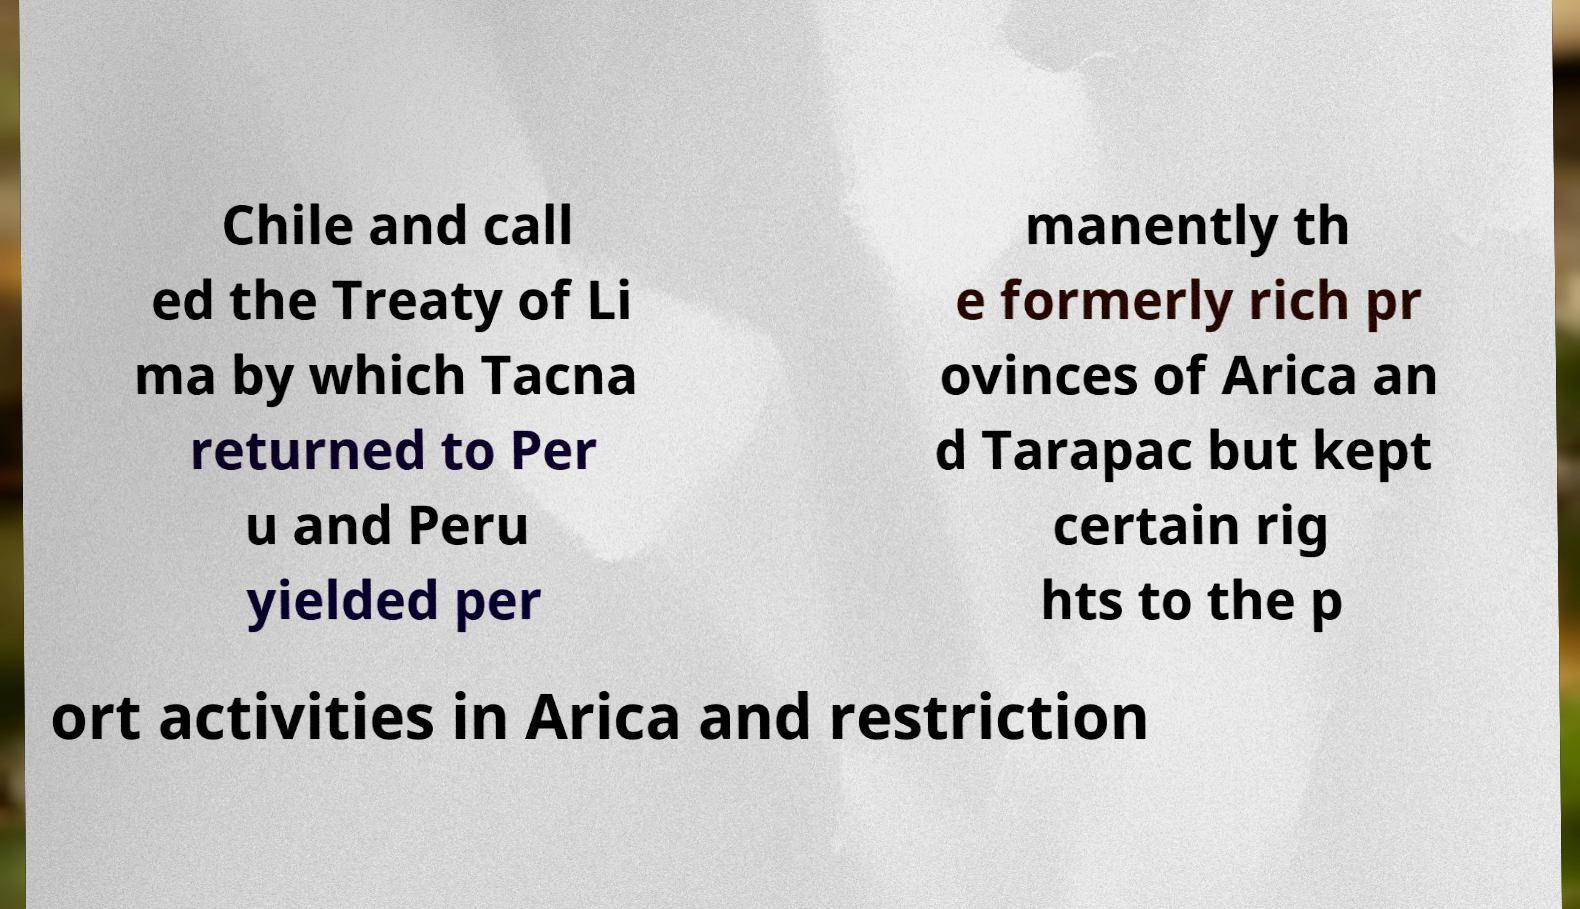Could you assist in decoding the text presented in this image and type it out clearly? Chile and call ed the Treaty of Li ma by which Tacna returned to Per u and Peru yielded per manently th e formerly rich pr ovinces of Arica an d Tarapac but kept certain rig hts to the p ort activities in Arica and restriction 